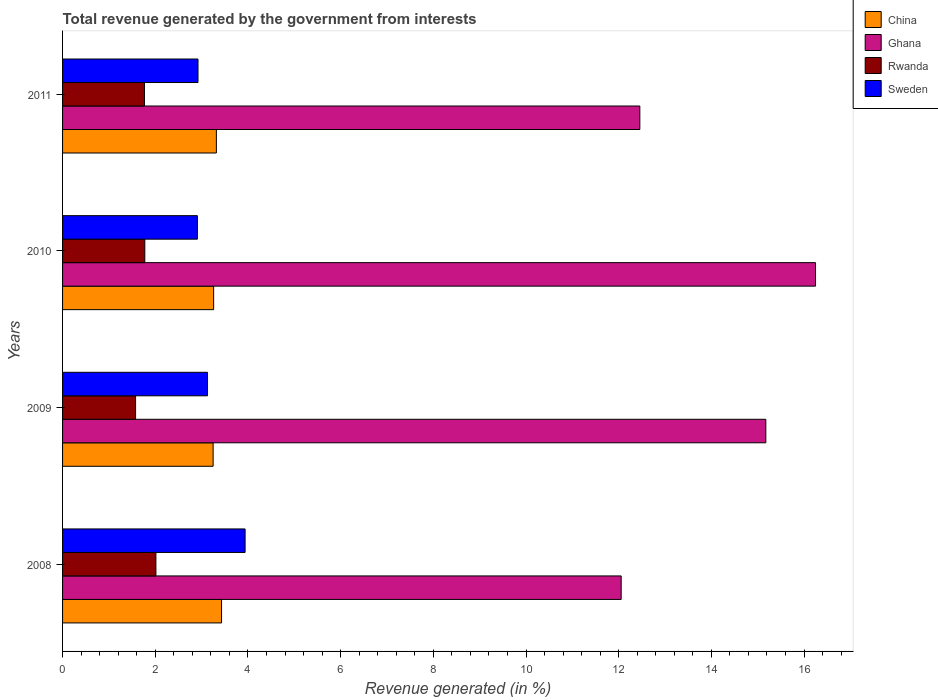Are the number of bars on each tick of the Y-axis equal?
Keep it short and to the point. Yes. What is the total revenue generated in Rwanda in 2009?
Your answer should be very brief. 1.58. Across all years, what is the maximum total revenue generated in Rwanda?
Your answer should be compact. 2.01. Across all years, what is the minimum total revenue generated in Sweden?
Give a very brief answer. 2.91. What is the total total revenue generated in Ghana in the graph?
Provide a succinct answer. 55.93. What is the difference between the total revenue generated in Ghana in 2009 and that in 2011?
Provide a succinct answer. 2.72. What is the difference between the total revenue generated in Rwanda in 2010 and the total revenue generated in Ghana in 2008?
Provide a succinct answer. -10.28. What is the average total revenue generated in Ghana per year?
Offer a terse response. 13.98. In the year 2009, what is the difference between the total revenue generated in China and total revenue generated in Ghana?
Offer a very short reply. -11.93. In how many years, is the total revenue generated in China greater than 13.2 %?
Your answer should be very brief. 0. What is the ratio of the total revenue generated in Ghana in 2009 to that in 2010?
Your response must be concise. 0.93. Is the total revenue generated in Ghana in 2008 less than that in 2010?
Your answer should be very brief. Yes. What is the difference between the highest and the second highest total revenue generated in Sweden?
Your answer should be compact. 0.81. What is the difference between the highest and the lowest total revenue generated in Sweden?
Make the answer very short. 1.03. In how many years, is the total revenue generated in China greater than the average total revenue generated in China taken over all years?
Provide a short and direct response. 2. Is the sum of the total revenue generated in Sweden in 2008 and 2011 greater than the maximum total revenue generated in China across all years?
Offer a terse response. Yes. What does the 2nd bar from the top in 2009 represents?
Give a very brief answer. Rwanda. What does the 3rd bar from the bottom in 2009 represents?
Your answer should be very brief. Rwanda. How many bars are there?
Offer a terse response. 16. Are all the bars in the graph horizontal?
Your answer should be very brief. Yes. How many years are there in the graph?
Your response must be concise. 4. Are the values on the major ticks of X-axis written in scientific E-notation?
Give a very brief answer. No. Does the graph contain any zero values?
Provide a short and direct response. No. Does the graph contain grids?
Ensure brevity in your answer.  No. How are the legend labels stacked?
Offer a very short reply. Vertical. What is the title of the graph?
Provide a short and direct response. Total revenue generated by the government from interests. Does "Canada" appear as one of the legend labels in the graph?
Offer a terse response. No. What is the label or title of the X-axis?
Provide a succinct answer. Revenue generated (in %). What is the Revenue generated (in %) in China in 2008?
Your answer should be compact. 3.43. What is the Revenue generated (in %) in Ghana in 2008?
Your response must be concise. 12.05. What is the Revenue generated (in %) in Rwanda in 2008?
Ensure brevity in your answer.  2.01. What is the Revenue generated (in %) of Sweden in 2008?
Your answer should be compact. 3.94. What is the Revenue generated (in %) of China in 2009?
Ensure brevity in your answer.  3.25. What is the Revenue generated (in %) in Ghana in 2009?
Give a very brief answer. 15.18. What is the Revenue generated (in %) of Rwanda in 2009?
Make the answer very short. 1.58. What is the Revenue generated (in %) in Sweden in 2009?
Make the answer very short. 3.13. What is the Revenue generated (in %) of China in 2010?
Offer a very short reply. 3.26. What is the Revenue generated (in %) of Ghana in 2010?
Your answer should be very brief. 16.25. What is the Revenue generated (in %) of Rwanda in 2010?
Make the answer very short. 1.77. What is the Revenue generated (in %) in Sweden in 2010?
Offer a very short reply. 2.91. What is the Revenue generated (in %) in China in 2011?
Offer a terse response. 3.32. What is the Revenue generated (in %) in Ghana in 2011?
Make the answer very short. 12.46. What is the Revenue generated (in %) in Rwanda in 2011?
Provide a succinct answer. 1.77. What is the Revenue generated (in %) of Sweden in 2011?
Your answer should be compact. 2.92. Across all years, what is the maximum Revenue generated (in %) of China?
Provide a succinct answer. 3.43. Across all years, what is the maximum Revenue generated (in %) in Ghana?
Give a very brief answer. 16.25. Across all years, what is the maximum Revenue generated (in %) of Rwanda?
Your response must be concise. 2.01. Across all years, what is the maximum Revenue generated (in %) in Sweden?
Provide a succinct answer. 3.94. Across all years, what is the minimum Revenue generated (in %) of China?
Offer a terse response. 3.25. Across all years, what is the minimum Revenue generated (in %) in Ghana?
Ensure brevity in your answer.  12.05. Across all years, what is the minimum Revenue generated (in %) of Rwanda?
Your answer should be compact. 1.58. Across all years, what is the minimum Revenue generated (in %) of Sweden?
Provide a short and direct response. 2.91. What is the total Revenue generated (in %) in China in the graph?
Your response must be concise. 13.26. What is the total Revenue generated (in %) of Ghana in the graph?
Ensure brevity in your answer.  55.93. What is the total Revenue generated (in %) in Rwanda in the graph?
Keep it short and to the point. 7.13. What is the total Revenue generated (in %) in Sweden in the graph?
Offer a terse response. 12.9. What is the difference between the Revenue generated (in %) in China in 2008 and that in 2009?
Your response must be concise. 0.18. What is the difference between the Revenue generated (in %) of Ghana in 2008 and that in 2009?
Give a very brief answer. -3.12. What is the difference between the Revenue generated (in %) of Rwanda in 2008 and that in 2009?
Provide a short and direct response. 0.44. What is the difference between the Revenue generated (in %) of Sweden in 2008 and that in 2009?
Ensure brevity in your answer.  0.81. What is the difference between the Revenue generated (in %) in China in 2008 and that in 2010?
Your answer should be compact. 0.17. What is the difference between the Revenue generated (in %) of Ghana in 2008 and that in 2010?
Your response must be concise. -4.19. What is the difference between the Revenue generated (in %) of Rwanda in 2008 and that in 2010?
Keep it short and to the point. 0.24. What is the difference between the Revenue generated (in %) of Sweden in 2008 and that in 2010?
Your answer should be compact. 1.03. What is the difference between the Revenue generated (in %) of China in 2008 and that in 2011?
Offer a very short reply. 0.11. What is the difference between the Revenue generated (in %) of Ghana in 2008 and that in 2011?
Provide a short and direct response. -0.4. What is the difference between the Revenue generated (in %) of Rwanda in 2008 and that in 2011?
Make the answer very short. 0.25. What is the difference between the Revenue generated (in %) in Sweden in 2008 and that in 2011?
Keep it short and to the point. 1.02. What is the difference between the Revenue generated (in %) in China in 2009 and that in 2010?
Provide a succinct answer. -0.01. What is the difference between the Revenue generated (in %) of Ghana in 2009 and that in 2010?
Your answer should be very brief. -1.07. What is the difference between the Revenue generated (in %) in Rwanda in 2009 and that in 2010?
Offer a very short reply. -0.2. What is the difference between the Revenue generated (in %) of Sweden in 2009 and that in 2010?
Your answer should be compact. 0.22. What is the difference between the Revenue generated (in %) in China in 2009 and that in 2011?
Your answer should be compact. -0.07. What is the difference between the Revenue generated (in %) of Ghana in 2009 and that in 2011?
Ensure brevity in your answer.  2.72. What is the difference between the Revenue generated (in %) of Rwanda in 2009 and that in 2011?
Your response must be concise. -0.19. What is the difference between the Revenue generated (in %) of Sweden in 2009 and that in 2011?
Provide a short and direct response. 0.21. What is the difference between the Revenue generated (in %) of China in 2010 and that in 2011?
Offer a terse response. -0.06. What is the difference between the Revenue generated (in %) of Ghana in 2010 and that in 2011?
Give a very brief answer. 3.79. What is the difference between the Revenue generated (in %) of Rwanda in 2010 and that in 2011?
Provide a short and direct response. 0.01. What is the difference between the Revenue generated (in %) of Sweden in 2010 and that in 2011?
Your answer should be very brief. -0.01. What is the difference between the Revenue generated (in %) in China in 2008 and the Revenue generated (in %) in Ghana in 2009?
Your response must be concise. -11.74. What is the difference between the Revenue generated (in %) of China in 2008 and the Revenue generated (in %) of Rwanda in 2009?
Provide a short and direct response. 1.86. What is the difference between the Revenue generated (in %) in China in 2008 and the Revenue generated (in %) in Sweden in 2009?
Make the answer very short. 0.3. What is the difference between the Revenue generated (in %) of Ghana in 2008 and the Revenue generated (in %) of Rwanda in 2009?
Offer a very short reply. 10.48. What is the difference between the Revenue generated (in %) in Ghana in 2008 and the Revenue generated (in %) in Sweden in 2009?
Ensure brevity in your answer.  8.93. What is the difference between the Revenue generated (in %) of Rwanda in 2008 and the Revenue generated (in %) of Sweden in 2009?
Keep it short and to the point. -1.11. What is the difference between the Revenue generated (in %) in China in 2008 and the Revenue generated (in %) in Ghana in 2010?
Your answer should be very brief. -12.82. What is the difference between the Revenue generated (in %) in China in 2008 and the Revenue generated (in %) in Rwanda in 2010?
Keep it short and to the point. 1.66. What is the difference between the Revenue generated (in %) in China in 2008 and the Revenue generated (in %) in Sweden in 2010?
Your answer should be compact. 0.52. What is the difference between the Revenue generated (in %) in Ghana in 2008 and the Revenue generated (in %) in Rwanda in 2010?
Your answer should be compact. 10.28. What is the difference between the Revenue generated (in %) in Ghana in 2008 and the Revenue generated (in %) in Sweden in 2010?
Keep it short and to the point. 9.14. What is the difference between the Revenue generated (in %) in Rwanda in 2008 and the Revenue generated (in %) in Sweden in 2010?
Provide a succinct answer. -0.89. What is the difference between the Revenue generated (in %) in China in 2008 and the Revenue generated (in %) in Ghana in 2011?
Ensure brevity in your answer.  -9.03. What is the difference between the Revenue generated (in %) in China in 2008 and the Revenue generated (in %) in Rwanda in 2011?
Give a very brief answer. 1.66. What is the difference between the Revenue generated (in %) in China in 2008 and the Revenue generated (in %) in Sweden in 2011?
Keep it short and to the point. 0.51. What is the difference between the Revenue generated (in %) of Ghana in 2008 and the Revenue generated (in %) of Rwanda in 2011?
Your answer should be very brief. 10.29. What is the difference between the Revenue generated (in %) in Ghana in 2008 and the Revenue generated (in %) in Sweden in 2011?
Offer a terse response. 9.13. What is the difference between the Revenue generated (in %) in Rwanda in 2008 and the Revenue generated (in %) in Sweden in 2011?
Offer a very short reply. -0.91. What is the difference between the Revenue generated (in %) of China in 2009 and the Revenue generated (in %) of Ghana in 2010?
Make the answer very short. -13. What is the difference between the Revenue generated (in %) of China in 2009 and the Revenue generated (in %) of Rwanda in 2010?
Provide a short and direct response. 1.47. What is the difference between the Revenue generated (in %) in China in 2009 and the Revenue generated (in %) in Sweden in 2010?
Make the answer very short. 0.34. What is the difference between the Revenue generated (in %) in Ghana in 2009 and the Revenue generated (in %) in Rwanda in 2010?
Offer a very short reply. 13.4. What is the difference between the Revenue generated (in %) of Ghana in 2009 and the Revenue generated (in %) of Sweden in 2010?
Ensure brevity in your answer.  12.27. What is the difference between the Revenue generated (in %) of Rwanda in 2009 and the Revenue generated (in %) of Sweden in 2010?
Your answer should be very brief. -1.33. What is the difference between the Revenue generated (in %) in China in 2009 and the Revenue generated (in %) in Ghana in 2011?
Provide a succinct answer. -9.21. What is the difference between the Revenue generated (in %) in China in 2009 and the Revenue generated (in %) in Rwanda in 2011?
Offer a very short reply. 1.48. What is the difference between the Revenue generated (in %) of China in 2009 and the Revenue generated (in %) of Sweden in 2011?
Provide a succinct answer. 0.33. What is the difference between the Revenue generated (in %) in Ghana in 2009 and the Revenue generated (in %) in Rwanda in 2011?
Your response must be concise. 13.41. What is the difference between the Revenue generated (in %) of Ghana in 2009 and the Revenue generated (in %) of Sweden in 2011?
Your answer should be very brief. 12.25. What is the difference between the Revenue generated (in %) in Rwanda in 2009 and the Revenue generated (in %) in Sweden in 2011?
Your answer should be compact. -1.35. What is the difference between the Revenue generated (in %) in China in 2010 and the Revenue generated (in %) in Ghana in 2011?
Provide a short and direct response. -9.2. What is the difference between the Revenue generated (in %) in China in 2010 and the Revenue generated (in %) in Rwanda in 2011?
Ensure brevity in your answer.  1.49. What is the difference between the Revenue generated (in %) in China in 2010 and the Revenue generated (in %) in Sweden in 2011?
Your answer should be very brief. 0.34. What is the difference between the Revenue generated (in %) of Ghana in 2010 and the Revenue generated (in %) of Rwanda in 2011?
Provide a succinct answer. 14.48. What is the difference between the Revenue generated (in %) in Ghana in 2010 and the Revenue generated (in %) in Sweden in 2011?
Your answer should be very brief. 13.33. What is the difference between the Revenue generated (in %) in Rwanda in 2010 and the Revenue generated (in %) in Sweden in 2011?
Your response must be concise. -1.15. What is the average Revenue generated (in %) in China per year?
Keep it short and to the point. 3.31. What is the average Revenue generated (in %) in Ghana per year?
Your answer should be compact. 13.98. What is the average Revenue generated (in %) in Rwanda per year?
Ensure brevity in your answer.  1.78. What is the average Revenue generated (in %) of Sweden per year?
Give a very brief answer. 3.22. In the year 2008, what is the difference between the Revenue generated (in %) in China and Revenue generated (in %) in Ghana?
Ensure brevity in your answer.  -8.62. In the year 2008, what is the difference between the Revenue generated (in %) of China and Revenue generated (in %) of Rwanda?
Your answer should be very brief. 1.42. In the year 2008, what is the difference between the Revenue generated (in %) in China and Revenue generated (in %) in Sweden?
Keep it short and to the point. -0.51. In the year 2008, what is the difference between the Revenue generated (in %) in Ghana and Revenue generated (in %) in Rwanda?
Provide a short and direct response. 10.04. In the year 2008, what is the difference between the Revenue generated (in %) in Ghana and Revenue generated (in %) in Sweden?
Provide a succinct answer. 8.11. In the year 2008, what is the difference between the Revenue generated (in %) of Rwanda and Revenue generated (in %) of Sweden?
Offer a terse response. -1.92. In the year 2009, what is the difference between the Revenue generated (in %) in China and Revenue generated (in %) in Ghana?
Give a very brief answer. -11.93. In the year 2009, what is the difference between the Revenue generated (in %) in China and Revenue generated (in %) in Rwanda?
Offer a very short reply. 1.67. In the year 2009, what is the difference between the Revenue generated (in %) of China and Revenue generated (in %) of Sweden?
Your answer should be very brief. 0.12. In the year 2009, what is the difference between the Revenue generated (in %) in Ghana and Revenue generated (in %) in Rwanda?
Provide a succinct answer. 13.6. In the year 2009, what is the difference between the Revenue generated (in %) of Ghana and Revenue generated (in %) of Sweden?
Offer a very short reply. 12.05. In the year 2009, what is the difference between the Revenue generated (in %) in Rwanda and Revenue generated (in %) in Sweden?
Provide a succinct answer. -1.55. In the year 2010, what is the difference between the Revenue generated (in %) in China and Revenue generated (in %) in Ghana?
Keep it short and to the point. -12.99. In the year 2010, what is the difference between the Revenue generated (in %) in China and Revenue generated (in %) in Rwanda?
Your response must be concise. 1.49. In the year 2010, what is the difference between the Revenue generated (in %) in China and Revenue generated (in %) in Sweden?
Make the answer very short. 0.35. In the year 2010, what is the difference between the Revenue generated (in %) in Ghana and Revenue generated (in %) in Rwanda?
Your answer should be compact. 14.47. In the year 2010, what is the difference between the Revenue generated (in %) in Ghana and Revenue generated (in %) in Sweden?
Ensure brevity in your answer.  13.34. In the year 2010, what is the difference between the Revenue generated (in %) of Rwanda and Revenue generated (in %) of Sweden?
Ensure brevity in your answer.  -1.13. In the year 2011, what is the difference between the Revenue generated (in %) in China and Revenue generated (in %) in Ghana?
Provide a short and direct response. -9.14. In the year 2011, what is the difference between the Revenue generated (in %) of China and Revenue generated (in %) of Rwanda?
Your response must be concise. 1.55. In the year 2011, what is the difference between the Revenue generated (in %) of China and Revenue generated (in %) of Sweden?
Your answer should be compact. 0.4. In the year 2011, what is the difference between the Revenue generated (in %) of Ghana and Revenue generated (in %) of Rwanda?
Give a very brief answer. 10.69. In the year 2011, what is the difference between the Revenue generated (in %) of Ghana and Revenue generated (in %) of Sweden?
Provide a succinct answer. 9.53. In the year 2011, what is the difference between the Revenue generated (in %) in Rwanda and Revenue generated (in %) in Sweden?
Give a very brief answer. -1.16. What is the ratio of the Revenue generated (in %) of China in 2008 to that in 2009?
Your answer should be very brief. 1.06. What is the ratio of the Revenue generated (in %) of Ghana in 2008 to that in 2009?
Provide a succinct answer. 0.79. What is the ratio of the Revenue generated (in %) of Rwanda in 2008 to that in 2009?
Your response must be concise. 1.28. What is the ratio of the Revenue generated (in %) of Sweden in 2008 to that in 2009?
Offer a terse response. 1.26. What is the ratio of the Revenue generated (in %) of China in 2008 to that in 2010?
Your answer should be very brief. 1.05. What is the ratio of the Revenue generated (in %) in Ghana in 2008 to that in 2010?
Offer a very short reply. 0.74. What is the ratio of the Revenue generated (in %) of Rwanda in 2008 to that in 2010?
Your answer should be very brief. 1.14. What is the ratio of the Revenue generated (in %) in Sweden in 2008 to that in 2010?
Your response must be concise. 1.35. What is the ratio of the Revenue generated (in %) of China in 2008 to that in 2011?
Keep it short and to the point. 1.03. What is the ratio of the Revenue generated (in %) in Rwanda in 2008 to that in 2011?
Keep it short and to the point. 1.14. What is the ratio of the Revenue generated (in %) of Sweden in 2008 to that in 2011?
Offer a terse response. 1.35. What is the ratio of the Revenue generated (in %) of Ghana in 2009 to that in 2010?
Provide a succinct answer. 0.93. What is the ratio of the Revenue generated (in %) in Rwanda in 2009 to that in 2010?
Give a very brief answer. 0.89. What is the ratio of the Revenue generated (in %) in Sweden in 2009 to that in 2010?
Provide a short and direct response. 1.08. What is the ratio of the Revenue generated (in %) in China in 2009 to that in 2011?
Provide a short and direct response. 0.98. What is the ratio of the Revenue generated (in %) of Ghana in 2009 to that in 2011?
Give a very brief answer. 1.22. What is the ratio of the Revenue generated (in %) in Rwanda in 2009 to that in 2011?
Offer a very short reply. 0.89. What is the ratio of the Revenue generated (in %) of Sweden in 2009 to that in 2011?
Provide a short and direct response. 1.07. What is the ratio of the Revenue generated (in %) in China in 2010 to that in 2011?
Ensure brevity in your answer.  0.98. What is the ratio of the Revenue generated (in %) in Ghana in 2010 to that in 2011?
Make the answer very short. 1.3. What is the difference between the highest and the second highest Revenue generated (in %) of China?
Keep it short and to the point. 0.11. What is the difference between the highest and the second highest Revenue generated (in %) in Ghana?
Make the answer very short. 1.07. What is the difference between the highest and the second highest Revenue generated (in %) in Rwanda?
Your answer should be very brief. 0.24. What is the difference between the highest and the second highest Revenue generated (in %) in Sweden?
Provide a short and direct response. 0.81. What is the difference between the highest and the lowest Revenue generated (in %) of China?
Make the answer very short. 0.18. What is the difference between the highest and the lowest Revenue generated (in %) in Ghana?
Your answer should be very brief. 4.19. What is the difference between the highest and the lowest Revenue generated (in %) of Rwanda?
Keep it short and to the point. 0.44. What is the difference between the highest and the lowest Revenue generated (in %) of Sweden?
Provide a short and direct response. 1.03. 